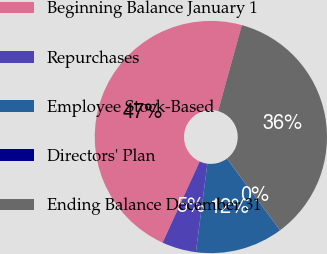Convert chart to OTSL. <chart><loc_0><loc_0><loc_500><loc_500><pie_chart><fcel>Beginning Balance January 1<fcel>Repurchases<fcel>Employee Stock-Based<fcel>Directors' Plan<fcel>Ending Balance December 31<nl><fcel>47.48%<fcel>4.76%<fcel>12.21%<fcel>0.02%<fcel>35.54%<nl></chart> 